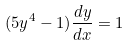<formula> <loc_0><loc_0><loc_500><loc_500>( 5 y ^ { 4 } - 1 ) \frac { d y } { d x } = 1</formula> 